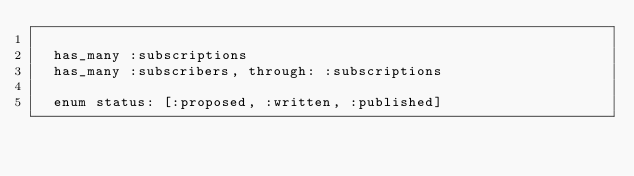<code> <loc_0><loc_0><loc_500><loc_500><_Ruby_>
  has_many :subscriptions
  has_many :subscribers, through: :subscriptions

  enum status: [:proposed, :written, :published]</code> 